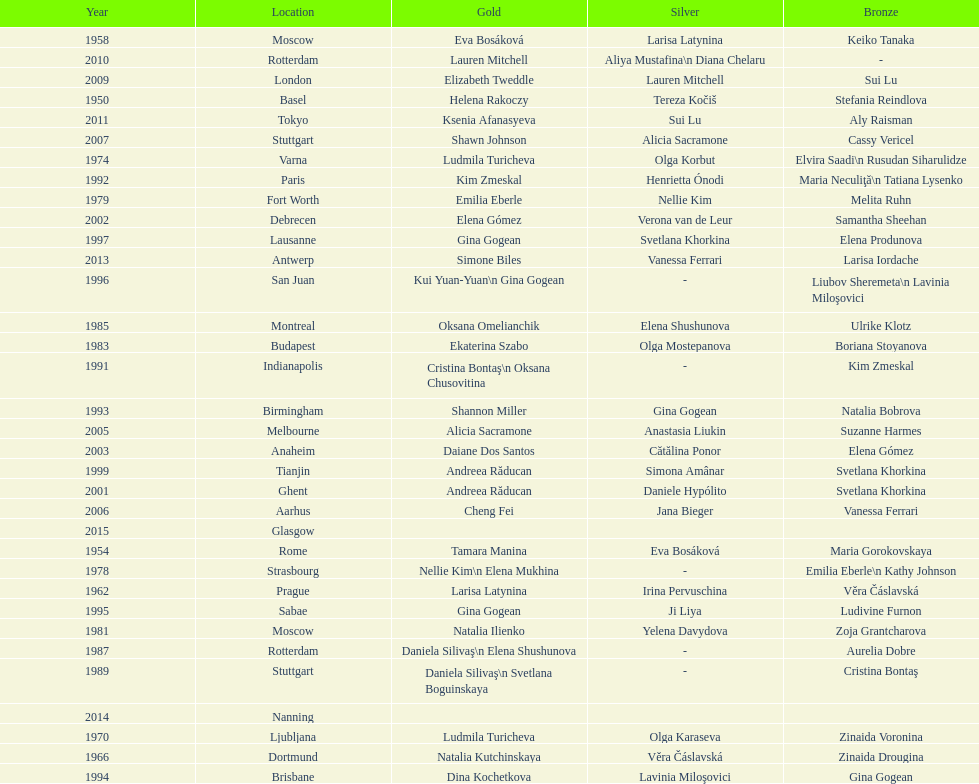How many times was the location in the united states? 3. 